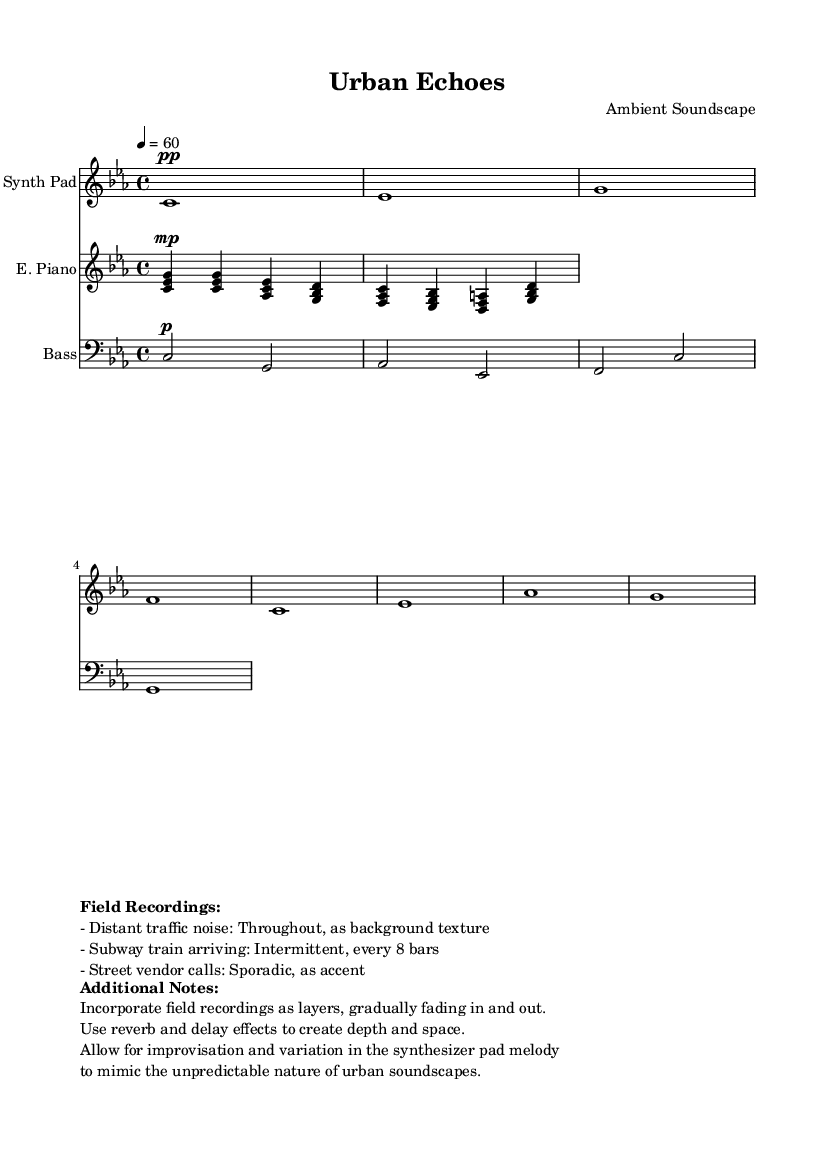What is the key signature of this music? The key signature is C minor, which has three flats (B♭, E♭, and A♭). It can be identified by locating the key signature section at the beginning of the score.
Answer: C minor What is the time signature of this piece? The time signature is 4/4, indicated at the beginning of the score. This means there are four beats in each measure, and the quarter note gets one beat.
Answer: 4/4 What is the tempo marking given for this music? The tempo marking is 60 beats per minute, which is indicated in the tempo notation in the global settings. This establishes the speed at which the music should be played.
Answer: 60 How many measures are there in the Synth Pad section? The Synth Pad section consists of 8 measures, which can be counted by observing the segment defined by each bar line in the staff.
Answer: 8 What type of effects are recommended for creating depth in the music? Reverb and delay effects are recommended, which are identified in the additional notes section of the score. These effects help to create a spacious atmosphere characteristic of ambient music.
Answer: Reverb and delay How frequently does the subway train arrive in this piece? The subway train arrives intermittently every 8 bars, as noted in the field recordings section. This provides a rhythmic texture that intersects with the music.
Answer: Every 8 bars What instruments are featured in this score? The featured instruments are Synth Pad, Electric Piano, and Bass, which are listed at the beginning of each staff in the score. These instruments contribute to the ambient soundscape.
Answer: Synth Pad, Electric Piano, Bass 